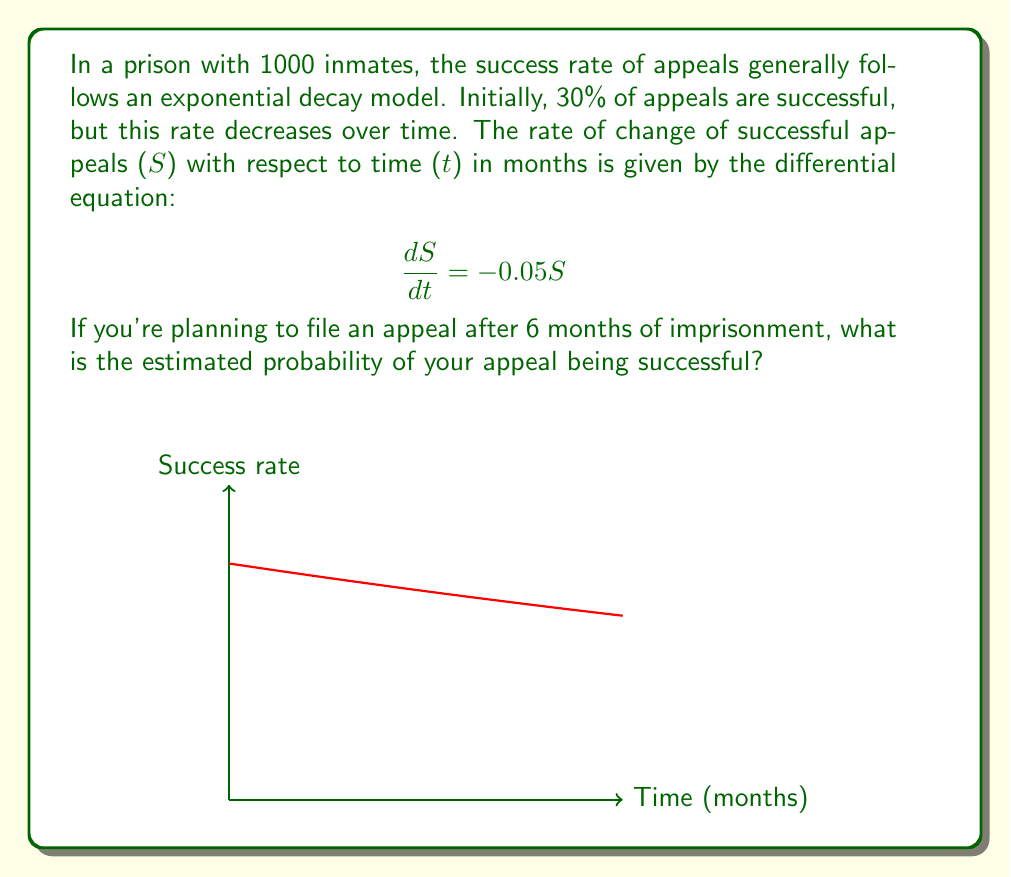Could you help me with this problem? To solve this problem, we need to follow these steps:

1) The given differential equation is a first-order linear equation:
   $$\frac{dS}{dt} = -0.05S$$

2) This equation can be solved by separation of variables:
   $$\frac{dS}{S} = -0.05dt$$

3) Integrating both sides:
   $$\int\frac{dS}{S} = \int-0.05dt$$
   $$\ln|S| = -0.05t + C$$

4) Taking the exponential of both sides:
   $$S = e^{-0.05t + C} = Ae^{-0.05t}$$
   where $A = e^C$ is a constant.

5) To find $A$, we use the initial condition. At $t=0$, 30% of appeals are successful:
   $$S(0) = 0.30 = Ae^{-0.05(0)} = A$$

6) Therefore, our solution is:
   $$S(t) = 0.30e^{-0.05t}$$

7) To find the probability after 6 months, we substitute $t=6$:
   $$S(6) = 0.30e^{-0.05(6)} = 0.30e^{-0.3} \approx 0.2223$$

8) Converting to a percentage:
   $$0.2223 \times 100\% \approx 22.23\%$$

Therefore, after 6 months, the estimated probability of a successful appeal is approximately 22.23%.
Answer: 22.23% 